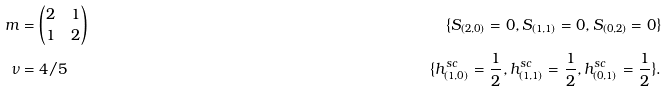<formula> <loc_0><loc_0><loc_500><loc_500>m & = \left ( \begin{matrix} 2 & 1 \\ 1 & 2 \end{matrix} \right ) \, & \{ S _ { ( 2 , 0 ) } = 0 , S _ { ( 1 , 1 ) } = 0 , S _ { ( 0 , 2 ) } = 0 \} \\ \nu & = 4 / 5 \, & \{ h ^ { s c } _ { ( 1 , 0 ) } = \frac { 1 } { 2 } , h ^ { s c } _ { ( 1 , 1 ) } = \frac { 1 } { 2 } , h ^ { s c } _ { ( 0 , 1 ) } = \frac { 1 } { 2 } \} .</formula> 